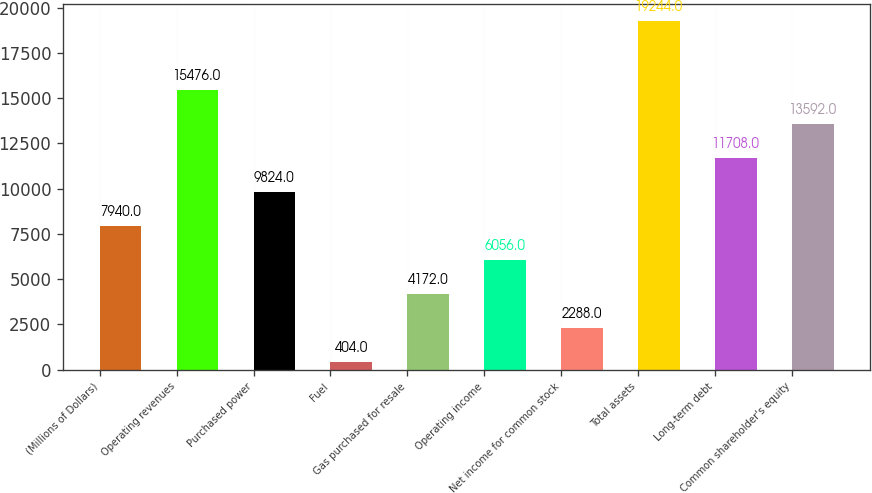Convert chart. <chart><loc_0><loc_0><loc_500><loc_500><bar_chart><fcel>(Millions of Dollars)<fcel>Operating revenues<fcel>Purchased power<fcel>Fuel<fcel>Gas purchased for resale<fcel>Operating income<fcel>Net income for common stock<fcel>Total assets<fcel>Long-term debt<fcel>Common shareholder's equity<nl><fcel>7940<fcel>15476<fcel>9824<fcel>404<fcel>4172<fcel>6056<fcel>2288<fcel>19244<fcel>11708<fcel>13592<nl></chart> 